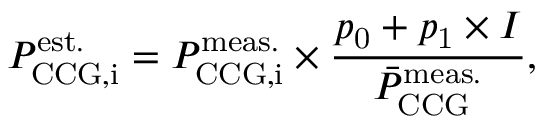Convert formula to latex. <formula><loc_0><loc_0><loc_500><loc_500>P _ { C C G , i } ^ { e s t . } = P _ { C C G , i } ^ { m e a s . } \times \frac { p _ { 0 } + p _ { 1 } \times I } { \bar { P } _ { C C G } ^ { m e a s . } } ,</formula> 